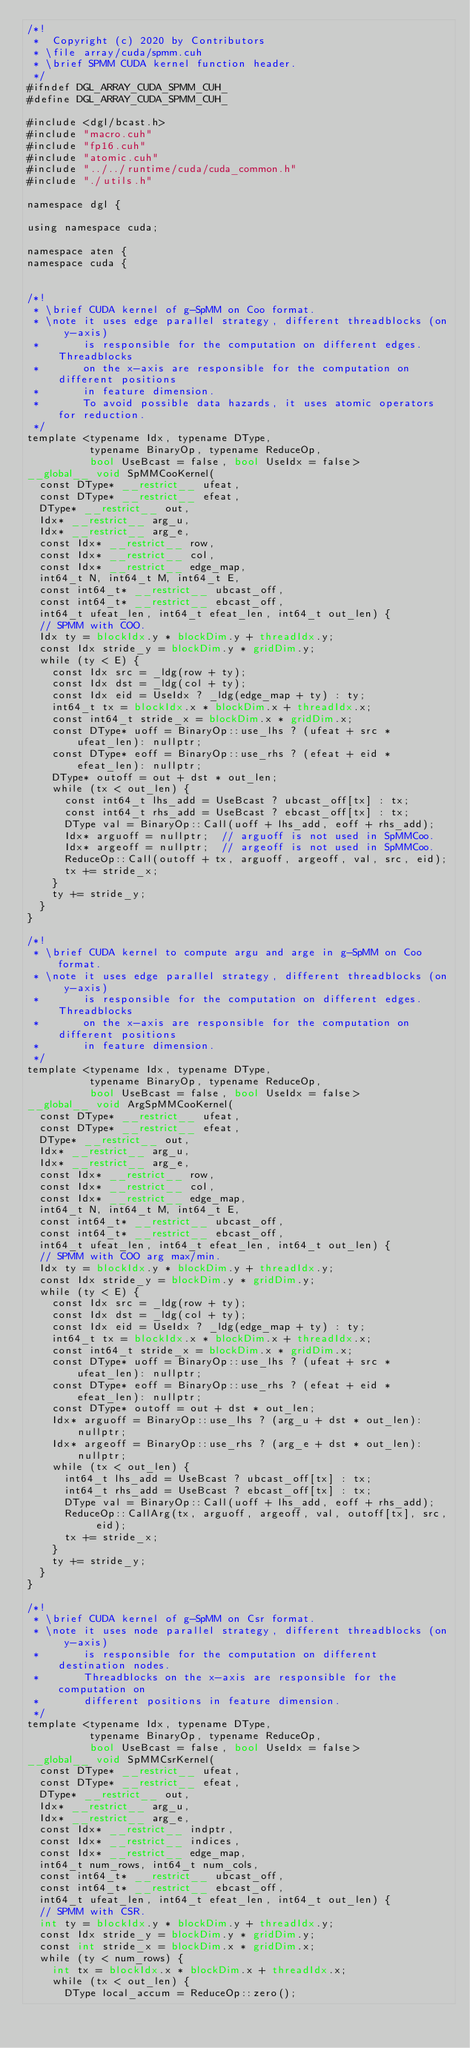Convert code to text. <code><loc_0><loc_0><loc_500><loc_500><_Cuda_>/*!
 *  Copyright (c) 2020 by Contributors
 * \file array/cuda/spmm.cuh
 * \brief SPMM CUDA kernel function header.
 */
#ifndef DGL_ARRAY_CUDA_SPMM_CUH_
#define DGL_ARRAY_CUDA_SPMM_CUH_

#include <dgl/bcast.h>
#include "macro.cuh"
#include "fp16.cuh"
#include "atomic.cuh"
#include "../../runtime/cuda/cuda_common.h"
#include "./utils.h"

namespace dgl {

using namespace cuda;

namespace aten {
namespace cuda {


/*!
 * \brief CUDA kernel of g-SpMM on Coo format.
 * \note it uses edge parallel strategy, different threadblocks (on y-axis)
 *       is responsible for the computation on different edges. Threadblocks
 *       on the x-axis are responsible for the computation on different positions
 *       in feature dimension.
 *       To avoid possible data hazards, it uses atomic operators for reduction.
 */
template <typename Idx, typename DType,
          typename BinaryOp, typename ReduceOp,
          bool UseBcast = false, bool UseIdx = false>
__global__ void SpMMCooKernel(
  const DType* __restrict__ ufeat,
  const DType* __restrict__ efeat,
  DType* __restrict__ out,
  Idx* __restrict__ arg_u,
  Idx* __restrict__ arg_e,
  const Idx* __restrict__ row,
  const Idx* __restrict__ col,
  const Idx* __restrict__ edge_map,
  int64_t N, int64_t M, int64_t E,
  const int64_t* __restrict__ ubcast_off,
  const int64_t* __restrict__ ebcast_off,
  int64_t ufeat_len, int64_t efeat_len, int64_t out_len) {
  // SPMM with COO.
  Idx ty = blockIdx.y * blockDim.y + threadIdx.y;
  const Idx stride_y = blockDim.y * gridDim.y;
  while (ty < E) {
    const Idx src = _ldg(row + ty);
    const Idx dst = _ldg(col + ty);
    const Idx eid = UseIdx ? _ldg(edge_map + ty) : ty;
    int64_t tx = blockIdx.x * blockDim.x + threadIdx.x;
    const int64_t stride_x = blockDim.x * gridDim.x;
    const DType* uoff = BinaryOp::use_lhs ? (ufeat + src * ufeat_len): nullptr;
    const DType* eoff = BinaryOp::use_rhs ? (efeat + eid * efeat_len): nullptr;
    DType* outoff = out + dst * out_len;
    while (tx < out_len) {
      const int64_t lhs_add = UseBcast ? ubcast_off[tx] : tx;
      const int64_t rhs_add = UseBcast ? ebcast_off[tx] : tx;
      DType val = BinaryOp::Call(uoff + lhs_add, eoff + rhs_add);
      Idx* arguoff = nullptr;  // arguoff is not used in SpMMCoo.
      Idx* argeoff = nullptr;  // argeoff is not used in SpMMCoo.
      ReduceOp::Call(outoff + tx, arguoff, argeoff, val, src, eid);
      tx += stride_x;
    }
    ty += stride_y;
  }
}

/*!
 * \brief CUDA kernel to compute argu and arge in g-SpMM on Coo format.
 * \note it uses edge parallel strategy, different threadblocks (on y-axis)
 *       is responsible for the computation on different edges. Threadblocks
 *       on the x-axis are responsible for the computation on different positions
 *       in feature dimension.
 */
template <typename Idx, typename DType,
          typename BinaryOp, typename ReduceOp,
          bool UseBcast = false, bool UseIdx = false>
__global__ void ArgSpMMCooKernel(
  const DType* __restrict__ ufeat,
  const DType* __restrict__ efeat,
  DType* __restrict__ out,
  Idx* __restrict__ arg_u,
  Idx* __restrict__ arg_e,
  const Idx* __restrict__ row,
  const Idx* __restrict__ col,
  const Idx* __restrict__ edge_map,
  int64_t N, int64_t M, int64_t E,
  const int64_t* __restrict__ ubcast_off,
  const int64_t* __restrict__ ebcast_off,
  int64_t ufeat_len, int64_t efeat_len, int64_t out_len) {
  // SPMM with COO arg max/min.
  Idx ty = blockIdx.y * blockDim.y + threadIdx.y;
  const Idx stride_y = blockDim.y * gridDim.y;
  while (ty < E) {
    const Idx src = _ldg(row + ty);
    const Idx dst = _ldg(col + ty);
    const Idx eid = UseIdx ? _ldg(edge_map + ty) : ty;
    int64_t tx = blockIdx.x * blockDim.x + threadIdx.x;
    const int64_t stride_x = blockDim.x * gridDim.x;
    const DType* uoff = BinaryOp::use_lhs ? (ufeat + src * ufeat_len): nullptr;
    const DType* eoff = BinaryOp::use_rhs ? (efeat + eid * efeat_len): nullptr;
    const DType* outoff = out + dst * out_len;
    Idx* arguoff = BinaryOp::use_lhs ? (arg_u + dst * out_len): nullptr;
    Idx* argeoff = BinaryOp::use_rhs ? (arg_e + dst * out_len): nullptr;
    while (tx < out_len) {
      int64_t lhs_add = UseBcast ? ubcast_off[tx] : tx;
      int64_t rhs_add = UseBcast ? ebcast_off[tx] : tx;
      DType val = BinaryOp::Call(uoff + lhs_add, eoff + rhs_add);
      ReduceOp::CallArg(tx, arguoff, argeoff, val, outoff[tx], src, eid);
      tx += stride_x;
    }
    ty += stride_y;
  }
}

/*!
 * \brief CUDA kernel of g-SpMM on Csr format.
 * \note it uses node parallel strategy, different threadblocks (on y-axis)
 *       is responsible for the computation on different destination nodes.
 *       Threadblocks on the x-axis are responsible for the computation on
 *       different positions in feature dimension.
 */
template <typename Idx, typename DType,
          typename BinaryOp, typename ReduceOp,
          bool UseBcast = false, bool UseIdx = false>
__global__ void SpMMCsrKernel(
  const DType* __restrict__ ufeat,
  const DType* __restrict__ efeat,
  DType* __restrict__ out,
  Idx* __restrict__ arg_u,
  Idx* __restrict__ arg_e,
  const Idx* __restrict__ indptr,
  const Idx* __restrict__ indices,
  const Idx* __restrict__ edge_map,
  int64_t num_rows, int64_t num_cols,
  const int64_t* __restrict__ ubcast_off,
  const int64_t* __restrict__ ebcast_off,
  int64_t ufeat_len, int64_t efeat_len, int64_t out_len) {
  // SPMM with CSR.
  int ty = blockIdx.y * blockDim.y + threadIdx.y;
  const Idx stride_y = blockDim.y * gridDim.y;
  const int stride_x = blockDim.x * gridDim.x;
  while (ty < num_rows) {
    int tx = blockIdx.x * blockDim.x + threadIdx.x;
    while (tx < out_len) {
      DType local_accum = ReduceOp::zero();</code> 